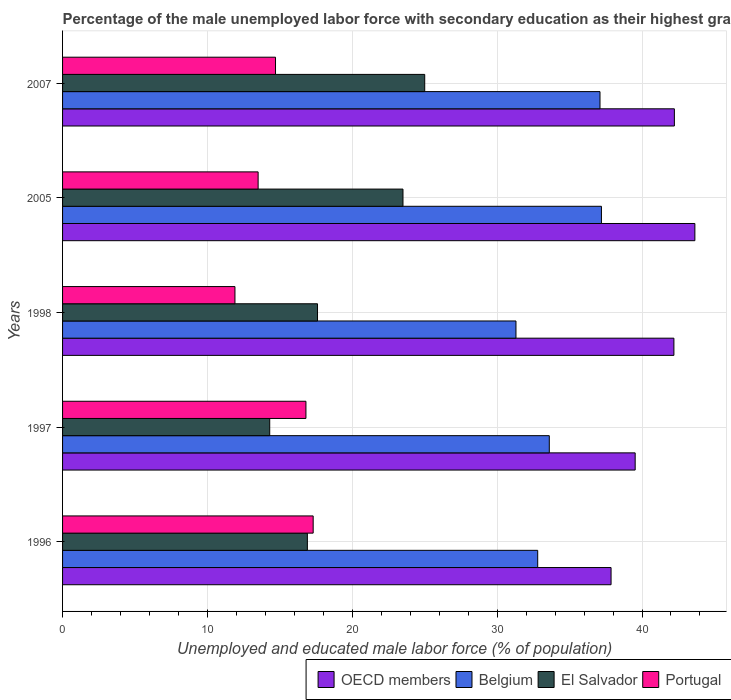How many different coloured bars are there?
Your response must be concise. 4. Are the number of bars per tick equal to the number of legend labels?
Ensure brevity in your answer.  Yes. What is the percentage of the unemployed male labor force with secondary education in Portugal in 1998?
Provide a short and direct response. 11.9. Across all years, what is the maximum percentage of the unemployed male labor force with secondary education in OECD members?
Provide a short and direct response. 43.65. Across all years, what is the minimum percentage of the unemployed male labor force with secondary education in Belgium?
Provide a succinct answer. 31.3. In which year was the percentage of the unemployed male labor force with secondary education in Belgium minimum?
Ensure brevity in your answer.  1998. What is the total percentage of the unemployed male labor force with secondary education in Portugal in the graph?
Your response must be concise. 74.2. What is the difference between the percentage of the unemployed male labor force with secondary education in Portugal in 1997 and that in 2005?
Make the answer very short. 3.3. What is the difference between the percentage of the unemployed male labor force with secondary education in OECD members in 2005 and the percentage of the unemployed male labor force with secondary education in Portugal in 1996?
Ensure brevity in your answer.  26.35. What is the average percentage of the unemployed male labor force with secondary education in Belgium per year?
Your answer should be compact. 34.4. In the year 2007, what is the difference between the percentage of the unemployed male labor force with secondary education in El Salvador and percentage of the unemployed male labor force with secondary education in Belgium?
Provide a short and direct response. -12.1. What is the ratio of the percentage of the unemployed male labor force with secondary education in OECD members in 1997 to that in 1998?
Make the answer very short. 0.94. What is the difference between the highest and the second highest percentage of the unemployed male labor force with secondary education in OECD members?
Your answer should be compact. 1.41. What is the difference between the highest and the lowest percentage of the unemployed male labor force with secondary education in OECD members?
Offer a terse response. 5.79. In how many years, is the percentage of the unemployed male labor force with secondary education in Belgium greater than the average percentage of the unemployed male labor force with secondary education in Belgium taken over all years?
Provide a short and direct response. 2. Is the sum of the percentage of the unemployed male labor force with secondary education in OECD members in 1996 and 1998 greater than the maximum percentage of the unemployed male labor force with secondary education in Portugal across all years?
Keep it short and to the point. Yes. Is it the case that in every year, the sum of the percentage of the unemployed male labor force with secondary education in El Salvador and percentage of the unemployed male labor force with secondary education in Belgium is greater than the sum of percentage of the unemployed male labor force with secondary education in Portugal and percentage of the unemployed male labor force with secondary education in OECD members?
Give a very brief answer. No. What does the 4th bar from the bottom in 1998 represents?
Your answer should be very brief. Portugal. How many bars are there?
Provide a short and direct response. 20. What is the difference between two consecutive major ticks on the X-axis?
Offer a very short reply. 10. Are the values on the major ticks of X-axis written in scientific E-notation?
Offer a very short reply. No. Where does the legend appear in the graph?
Keep it short and to the point. Bottom right. How many legend labels are there?
Your answer should be compact. 4. How are the legend labels stacked?
Keep it short and to the point. Horizontal. What is the title of the graph?
Provide a succinct answer. Percentage of the male unemployed labor force with secondary education as their highest grade. Does "South Sudan" appear as one of the legend labels in the graph?
Offer a terse response. No. What is the label or title of the X-axis?
Your answer should be compact. Unemployed and educated male labor force (% of population). What is the Unemployed and educated male labor force (% of population) of OECD members in 1996?
Ensure brevity in your answer.  37.86. What is the Unemployed and educated male labor force (% of population) in Belgium in 1996?
Offer a terse response. 32.8. What is the Unemployed and educated male labor force (% of population) in El Salvador in 1996?
Give a very brief answer. 16.9. What is the Unemployed and educated male labor force (% of population) of Portugal in 1996?
Offer a very short reply. 17.3. What is the Unemployed and educated male labor force (% of population) in OECD members in 1997?
Make the answer very short. 39.53. What is the Unemployed and educated male labor force (% of population) of Belgium in 1997?
Your response must be concise. 33.6. What is the Unemployed and educated male labor force (% of population) of El Salvador in 1997?
Your answer should be compact. 14.3. What is the Unemployed and educated male labor force (% of population) in Portugal in 1997?
Provide a short and direct response. 16.8. What is the Unemployed and educated male labor force (% of population) in OECD members in 1998?
Provide a succinct answer. 42.2. What is the Unemployed and educated male labor force (% of population) in Belgium in 1998?
Your answer should be compact. 31.3. What is the Unemployed and educated male labor force (% of population) of El Salvador in 1998?
Provide a succinct answer. 17.6. What is the Unemployed and educated male labor force (% of population) of Portugal in 1998?
Ensure brevity in your answer.  11.9. What is the Unemployed and educated male labor force (% of population) in OECD members in 2005?
Your answer should be compact. 43.65. What is the Unemployed and educated male labor force (% of population) in Belgium in 2005?
Give a very brief answer. 37.2. What is the Unemployed and educated male labor force (% of population) in Portugal in 2005?
Your response must be concise. 13.5. What is the Unemployed and educated male labor force (% of population) in OECD members in 2007?
Keep it short and to the point. 42.24. What is the Unemployed and educated male labor force (% of population) in Belgium in 2007?
Offer a very short reply. 37.1. What is the Unemployed and educated male labor force (% of population) in El Salvador in 2007?
Your answer should be very brief. 25. What is the Unemployed and educated male labor force (% of population) in Portugal in 2007?
Ensure brevity in your answer.  14.7. Across all years, what is the maximum Unemployed and educated male labor force (% of population) of OECD members?
Your answer should be very brief. 43.65. Across all years, what is the maximum Unemployed and educated male labor force (% of population) of Belgium?
Offer a very short reply. 37.2. Across all years, what is the maximum Unemployed and educated male labor force (% of population) of El Salvador?
Provide a succinct answer. 25. Across all years, what is the maximum Unemployed and educated male labor force (% of population) of Portugal?
Give a very brief answer. 17.3. Across all years, what is the minimum Unemployed and educated male labor force (% of population) in OECD members?
Offer a terse response. 37.86. Across all years, what is the minimum Unemployed and educated male labor force (% of population) of Belgium?
Provide a succinct answer. 31.3. Across all years, what is the minimum Unemployed and educated male labor force (% of population) of El Salvador?
Your answer should be very brief. 14.3. Across all years, what is the minimum Unemployed and educated male labor force (% of population) in Portugal?
Keep it short and to the point. 11.9. What is the total Unemployed and educated male labor force (% of population) of OECD members in the graph?
Offer a very short reply. 205.48. What is the total Unemployed and educated male labor force (% of population) of Belgium in the graph?
Offer a terse response. 172. What is the total Unemployed and educated male labor force (% of population) in El Salvador in the graph?
Your answer should be very brief. 97.3. What is the total Unemployed and educated male labor force (% of population) of Portugal in the graph?
Keep it short and to the point. 74.2. What is the difference between the Unemployed and educated male labor force (% of population) in OECD members in 1996 and that in 1997?
Offer a terse response. -1.67. What is the difference between the Unemployed and educated male labor force (% of population) of Portugal in 1996 and that in 1997?
Provide a short and direct response. 0.5. What is the difference between the Unemployed and educated male labor force (% of population) in OECD members in 1996 and that in 1998?
Give a very brief answer. -4.34. What is the difference between the Unemployed and educated male labor force (% of population) of Belgium in 1996 and that in 1998?
Keep it short and to the point. 1.5. What is the difference between the Unemployed and educated male labor force (% of population) of El Salvador in 1996 and that in 1998?
Ensure brevity in your answer.  -0.7. What is the difference between the Unemployed and educated male labor force (% of population) of OECD members in 1996 and that in 2005?
Make the answer very short. -5.79. What is the difference between the Unemployed and educated male labor force (% of population) in Portugal in 1996 and that in 2005?
Provide a succinct answer. 3.8. What is the difference between the Unemployed and educated male labor force (% of population) of OECD members in 1996 and that in 2007?
Your answer should be compact. -4.37. What is the difference between the Unemployed and educated male labor force (% of population) of Belgium in 1996 and that in 2007?
Your answer should be compact. -4.3. What is the difference between the Unemployed and educated male labor force (% of population) of Portugal in 1996 and that in 2007?
Offer a very short reply. 2.6. What is the difference between the Unemployed and educated male labor force (% of population) in OECD members in 1997 and that in 1998?
Give a very brief answer. -2.67. What is the difference between the Unemployed and educated male labor force (% of population) of Portugal in 1997 and that in 1998?
Offer a very short reply. 4.9. What is the difference between the Unemployed and educated male labor force (% of population) of OECD members in 1997 and that in 2005?
Offer a terse response. -4.12. What is the difference between the Unemployed and educated male labor force (% of population) in Portugal in 1997 and that in 2005?
Your answer should be compact. 3.3. What is the difference between the Unemployed and educated male labor force (% of population) of OECD members in 1997 and that in 2007?
Make the answer very short. -2.71. What is the difference between the Unemployed and educated male labor force (% of population) in El Salvador in 1997 and that in 2007?
Give a very brief answer. -10.7. What is the difference between the Unemployed and educated male labor force (% of population) of OECD members in 1998 and that in 2005?
Provide a succinct answer. -1.45. What is the difference between the Unemployed and educated male labor force (% of population) of Belgium in 1998 and that in 2005?
Offer a very short reply. -5.9. What is the difference between the Unemployed and educated male labor force (% of population) of OECD members in 1998 and that in 2007?
Give a very brief answer. -0.03. What is the difference between the Unemployed and educated male labor force (% of population) in OECD members in 2005 and that in 2007?
Give a very brief answer. 1.41. What is the difference between the Unemployed and educated male labor force (% of population) in Belgium in 2005 and that in 2007?
Offer a very short reply. 0.1. What is the difference between the Unemployed and educated male labor force (% of population) in El Salvador in 2005 and that in 2007?
Ensure brevity in your answer.  -1.5. What is the difference between the Unemployed and educated male labor force (% of population) of Portugal in 2005 and that in 2007?
Your response must be concise. -1.2. What is the difference between the Unemployed and educated male labor force (% of population) of OECD members in 1996 and the Unemployed and educated male labor force (% of population) of Belgium in 1997?
Provide a short and direct response. 4.26. What is the difference between the Unemployed and educated male labor force (% of population) of OECD members in 1996 and the Unemployed and educated male labor force (% of population) of El Salvador in 1997?
Provide a short and direct response. 23.56. What is the difference between the Unemployed and educated male labor force (% of population) of OECD members in 1996 and the Unemployed and educated male labor force (% of population) of Portugal in 1997?
Your response must be concise. 21.06. What is the difference between the Unemployed and educated male labor force (% of population) of Belgium in 1996 and the Unemployed and educated male labor force (% of population) of El Salvador in 1997?
Ensure brevity in your answer.  18.5. What is the difference between the Unemployed and educated male labor force (% of population) of El Salvador in 1996 and the Unemployed and educated male labor force (% of population) of Portugal in 1997?
Your response must be concise. 0.1. What is the difference between the Unemployed and educated male labor force (% of population) of OECD members in 1996 and the Unemployed and educated male labor force (% of population) of Belgium in 1998?
Provide a short and direct response. 6.56. What is the difference between the Unemployed and educated male labor force (% of population) of OECD members in 1996 and the Unemployed and educated male labor force (% of population) of El Salvador in 1998?
Your answer should be compact. 20.26. What is the difference between the Unemployed and educated male labor force (% of population) in OECD members in 1996 and the Unemployed and educated male labor force (% of population) in Portugal in 1998?
Keep it short and to the point. 25.96. What is the difference between the Unemployed and educated male labor force (% of population) of Belgium in 1996 and the Unemployed and educated male labor force (% of population) of El Salvador in 1998?
Ensure brevity in your answer.  15.2. What is the difference between the Unemployed and educated male labor force (% of population) of Belgium in 1996 and the Unemployed and educated male labor force (% of population) of Portugal in 1998?
Ensure brevity in your answer.  20.9. What is the difference between the Unemployed and educated male labor force (% of population) in El Salvador in 1996 and the Unemployed and educated male labor force (% of population) in Portugal in 1998?
Your response must be concise. 5. What is the difference between the Unemployed and educated male labor force (% of population) of OECD members in 1996 and the Unemployed and educated male labor force (% of population) of Belgium in 2005?
Your response must be concise. 0.66. What is the difference between the Unemployed and educated male labor force (% of population) in OECD members in 1996 and the Unemployed and educated male labor force (% of population) in El Salvador in 2005?
Ensure brevity in your answer.  14.36. What is the difference between the Unemployed and educated male labor force (% of population) of OECD members in 1996 and the Unemployed and educated male labor force (% of population) of Portugal in 2005?
Your answer should be very brief. 24.36. What is the difference between the Unemployed and educated male labor force (% of population) in Belgium in 1996 and the Unemployed and educated male labor force (% of population) in El Salvador in 2005?
Offer a terse response. 9.3. What is the difference between the Unemployed and educated male labor force (% of population) of Belgium in 1996 and the Unemployed and educated male labor force (% of population) of Portugal in 2005?
Offer a very short reply. 19.3. What is the difference between the Unemployed and educated male labor force (% of population) in El Salvador in 1996 and the Unemployed and educated male labor force (% of population) in Portugal in 2005?
Provide a short and direct response. 3.4. What is the difference between the Unemployed and educated male labor force (% of population) in OECD members in 1996 and the Unemployed and educated male labor force (% of population) in Belgium in 2007?
Your response must be concise. 0.76. What is the difference between the Unemployed and educated male labor force (% of population) in OECD members in 1996 and the Unemployed and educated male labor force (% of population) in El Salvador in 2007?
Offer a very short reply. 12.86. What is the difference between the Unemployed and educated male labor force (% of population) in OECD members in 1996 and the Unemployed and educated male labor force (% of population) in Portugal in 2007?
Give a very brief answer. 23.16. What is the difference between the Unemployed and educated male labor force (% of population) in El Salvador in 1996 and the Unemployed and educated male labor force (% of population) in Portugal in 2007?
Offer a very short reply. 2.2. What is the difference between the Unemployed and educated male labor force (% of population) of OECD members in 1997 and the Unemployed and educated male labor force (% of population) of Belgium in 1998?
Ensure brevity in your answer.  8.23. What is the difference between the Unemployed and educated male labor force (% of population) of OECD members in 1997 and the Unemployed and educated male labor force (% of population) of El Salvador in 1998?
Give a very brief answer. 21.93. What is the difference between the Unemployed and educated male labor force (% of population) of OECD members in 1997 and the Unemployed and educated male labor force (% of population) of Portugal in 1998?
Keep it short and to the point. 27.63. What is the difference between the Unemployed and educated male labor force (% of population) of Belgium in 1997 and the Unemployed and educated male labor force (% of population) of El Salvador in 1998?
Provide a succinct answer. 16. What is the difference between the Unemployed and educated male labor force (% of population) in Belgium in 1997 and the Unemployed and educated male labor force (% of population) in Portugal in 1998?
Your answer should be very brief. 21.7. What is the difference between the Unemployed and educated male labor force (% of population) in OECD members in 1997 and the Unemployed and educated male labor force (% of population) in Belgium in 2005?
Keep it short and to the point. 2.33. What is the difference between the Unemployed and educated male labor force (% of population) in OECD members in 1997 and the Unemployed and educated male labor force (% of population) in El Salvador in 2005?
Provide a short and direct response. 16.03. What is the difference between the Unemployed and educated male labor force (% of population) of OECD members in 1997 and the Unemployed and educated male labor force (% of population) of Portugal in 2005?
Offer a terse response. 26.03. What is the difference between the Unemployed and educated male labor force (% of population) of Belgium in 1997 and the Unemployed and educated male labor force (% of population) of Portugal in 2005?
Keep it short and to the point. 20.1. What is the difference between the Unemployed and educated male labor force (% of population) in OECD members in 1997 and the Unemployed and educated male labor force (% of population) in Belgium in 2007?
Your response must be concise. 2.43. What is the difference between the Unemployed and educated male labor force (% of population) of OECD members in 1997 and the Unemployed and educated male labor force (% of population) of El Salvador in 2007?
Make the answer very short. 14.53. What is the difference between the Unemployed and educated male labor force (% of population) of OECD members in 1997 and the Unemployed and educated male labor force (% of population) of Portugal in 2007?
Your answer should be compact. 24.83. What is the difference between the Unemployed and educated male labor force (% of population) of Belgium in 1997 and the Unemployed and educated male labor force (% of population) of El Salvador in 2007?
Your response must be concise. 8.6. What is the difference between the Unemployed and educated male labor force (% of population) of El Salvador in 1997 and the Unemployed and educated male labor force (% of population) of Portugal in 2007?
Keep it short and to the point. -0.4. What is the difference between the Unemployed and educated male labor force (% of population) of OECD members in 1998 and the Unemployed and educated male labor force (% of population) of Belgium in 2005?
Offer a terse response. 5. What is the difference between the Unemployed and educated male labor force (% of population) of OECD members in 1998 and the Unemployed and educated male labor force (% of population) of El Salvador in 2005?
Provide a succinct answer. 18.7. What is the difference between the Unemployed and educated male labor force (% of population) of OECD members in 1998 and the Unemployed and educated male labor force (% of population) of Portugal in 2005?
Ensure brevity in your answer.  28.7. What is the difference between the Unemployed and educated male labor force (% of population) of Belgium in 1998 and the Unemployed and educated male labor force (% of population) of Portugal in 2005?
Offer a terse response. 17.8. What is the difference between the Unemployed and educated male labor force (% of population) in El Salvador in 1998 and the Unemployed and educated male labor force (% of population) in Portugal in 2005?
Provide a succinct answer. 4.1. What is the difference between the Unemployed and educated male labor force (% of population) in OECD members in 1998 and the Unemployed and educated male labor force (% of population) in Belgium in 2007?
Your response must be concise. 5.1. What is the difference between the Unemployed and educated male labor force (% of population) in OECD members in 1998 and the Unemployed and educated male labor force (% of population) in El Salvador in 2007?
Your answer should be very brief. 17.2. What is the difference between the Unemployed and educated male labor force (% of population) in OECD members in 1998 and the Unemployed and educated male labor force (% of population) in Portugal in 2007?
Provide a succinct answer. 27.5. What is the difference between the Unemployed and educated male labor force (% of population) of Belgium in 1998 and the Unemployed and educated male labor force (% of population) of El Salvador in 2007?
Your answer should be compact. 6.3. What is the difference between the Unemployed and educated male labor force (% of population) of Belgium in 1998 and the Unemployed and educated male labor force (% of population) of Portugal in 2007?
Ensure brevity in your answer.  16.6. What is the difference between the Unemployed and educated male labor force (% of population) of OECD members in 2005 and the Unemployed and educated male labor force (% of population) of Belgium in 2007?
Your answer should be compact. 6.55. What is the difference between the Unemployed and educated male labor force (% of population) in OECD members in 2005 and the Unemployed and educated male labor force (% of population) in El Salvador in 2007?
Provide a short and direct response. 18.65. What is the difference between the Unemployed and educated male labor force (% of population) in OECD members in 2005 and the Unemployed and educated male labor force (% of population) in Portugal in 2007?
Provide a succinct answer. 28.95. What is the difference between the Unemployed and educated male labor force (% of population) in Belgium in 2005 and the Unemployed and educated male labor force (% of population) in Portugal in 2007?
Your answer should be very brief. 22.5. What is the difference between the Unemployed and educated male labor force (% of population) in El Salvador in 2005 and the Unemployed and educated male labor force (% of population) in Portugal in 2007?
Offer a terse response. 8.8. What is the average Unemployed and educated male labor force (% of population) in OECD members per year?
Provide a short and direct response. 41.1. What is the average Unemployed and educated male labor force (% of population) in Belgium per year?
Ensure brevity in your answer.  34.4. What is the average Unemployed and educated male labor force (% of population) of El Salvador per year?
Your answer should be compact. 19.46. What is the average Unemployed and educated male labor force (% of population) of Portugal per year?
Your answer should be compact. 14.84. In the year 1996, what is the difference between the Unemployed and educated male labor force (% of population) in OECD members and Unemployed and educated male labor force (% of population) in Belgium?
Your response must be concise. 5.06. In the year 1996, what is the difference between the Unemployed and educated male labor force (% of population) in OECD members and Unemployed and educated male labor force (% of population) in El Salvador?
Your answer should be very brief. 20.96. In the year 1996, what is the difference between the Unemployed and educated male labor force (% of population) in OECD members and Unemployed and educated male labor force (% of population) in Portugal?
Provide a succinct answer. 20.56. In the year 1996, what is the difference between the Unemployed and educated male labor force (% of population) of El Salvador and Unemployed and educated male labor force (% of population) of Portugal?
Make the answer very short. -0.4. In the year 1997, what is the difference between the Unemployed and educated male labor force (% of population) of OECD members and Unemployed and educated male labor force (% of population) of Belgium?
Offer a very short reply. 5.93. In the year 1997, what is the difference between the Unemployed and educated male labor force (% of population) in OECD members and Unemployed and educated male labor force (% of population) in El Salvador?
Provide a succinct answer. 25.23. In the year 1997, what is the difference between the Unemployed and educated male labor force (% of population) of OECD members and Unemployed and educated male labor force (% of population) of Portugal?
Make the answer very short. 22.73. In the year 1997, what is the difference between the Unemployed and educated male labor force (% of population) of Belgium and Unemployed and educated male labor force (% of population) of El Salvador?
Offer a terse response. 19.3. In the year 1997, what is the difference between the Unemployed and educated male labor force (% of population) of Belgium and Unemployed and educated male labor force (% of population) of Portugal?
Make the answer very short. 16.8. In the year 1998, what is the difference between the Unemployed and educated male labor force (% of population) in OECD members and Unemployed and educated male labor force (% of population) in Belgium?
Keep it short and to the point. 10.9. In the year 1998, what is the difference between the Unemployed and educated male labor force (% of population) of OECD members and Unemployed and educated male labor force (% of population) of El Salvador?
Ensure brevity in your answer.  24.6. In the year 1998, what is the difference between the Unemployed and educated male labor force (% of population) in OECD members and Unemployed and educated male labor force (% of population) in Portugal?
Provide a succinct answer. 30.3. In the year 1998, what is the difference between the Unemployed and educated male labor force (% of population) of Belgium and Unemployed and educated male labor force (% of population) of Portugal?
Keep it short and to the point. 19.4. In the year 2005, what is the difference between the Unemployed and educated male labor force (% of population) of OECD members and Unemployed and educated male labor force (% of population) of Belgium?
Provide a succinct answer. 6.45. In the year 2005, what is the difference between the Unemployed and educated male labor force (% of population) of OECD members and Unemployed and educated male labor force (% of population) of El Salvador?
Give a very brief answer. 20.15. In the year 2005, what is the difference between the Unemployed and educated male labor force (% of population) in OECD members and Unemployed and educated male labor force (% of population) in Portugal?
Your answer should be compact. 30.15. In the year 2005, what is the difference between the Unemployed and educated male labor force (% of population) of Belgium and Unemployed and educated male labor force (% of population) of Portugal?
Keep it short and to the point. 23.7. In the year 2007, what is the difference between the Unemployed and educated male labor force (% of population) of OECD members and Unemployed and educated male labor force (% of population) of Belgium?
Your answer should be very brief. 5.14. In the year 2007, what is the difference between the Unemployed and educated male labor force (% of population) in OECD members and Unemployed and educated male labor force (% of population) in El Salvador?
Your response must be concise. 17.24. In the year 2007, what is the difference between the Unemployed and educated male labor force (% of population) in OECD members and Unemployed and educated male labor force (% of population) in Portugal?
Offer a terse response. 27.54. In the year 2007, what is the difference between the Unemployed and educated male labor force (% of population) in Belgium and Unemployed and educated male labor force (% of population) in Portugal?
Make the answer very short. 22.4. In the year 2007, what is the difference between the Unemployed and educated male labor force (% of population) of El Salvador and Unemployed and educated male labor force (% of population) of Portugal?
Provide a short and direct response. 10.3. What is the ratio of the Unemployed and educated male labor force (% of population) of OECD members in 1996 to that in 1997?
Provide a short and direct response. 0.96. What is the ratio of the Unemployed and educated male labor force (% of population) of Belgium in 1996 to that in 1997?
Provide a short and direct response. 0.98. What is the ratio of the Unemployed and educated male labor force (% of population) of El Salvador in 1996 to that in 1997?
Make the answer very short. 1.18. What is the ratio of the Unemployed and educated male labor force (% of population) in Portugal in 1996 to that in 1997?
Offer a terse response. 1.03. What is the ratio of the Unemployed and educated male labor force (% of population) in OECD members in 1996 to that in 1998?
Provide a short and direct response. 0.9. What is the ratio of the Unemployed and educated male labor force (% of population) in Belgium in 1996 to that in 1998?
Make the answer very short. 1.05. What is the ratio of the Unemployed and educated male labor force (% of population) in El Salvador in 1996 to that in 1998?
Your answer should be compact. 0.96. What is the ratio of the Unemployed and educated male labor force (% of population) of Portugal in 1996 to that in 1998?
Provide a succinct answer. 1.45. What is the ratio of the Unemployed and educated male labor force (% of population) of OECD members in 1996 to that in 2005?
Your response must be concise. 0.87. What is the ratio of the Unemployed and educated male labor force (% of population) in Belgium in 1996 to that in 2005?
Your answer should be very brief. 0.88. What is the ratio of the Unemployed and educated male labor force (% of population) in El Salvador in 1996 to that in 2005?
Provide a short and direct response. 0.72. What is the ratio of the Unemployed and educated male labor force (% of population) in Portugal in 1996 to that in 2005?
Provide a succinct answer. 1.28. What is the ratio of the Unemployed and educated male labor force (% of population) of OECD members in 1996 to that in 2007?
Offer a very short reply. 0.9. What is the ratio of the Unemployed and educated male labor force (% of population) of Belgium in 1996 to that in 2007?
Keep it short and to the point. 0.88. What is the ratio of the Unemployed and educated male labor force (% of population) of El Salvador in 1996 to that in 2007?
Your answer should be compact. 0.68. What is the ratio of the Unemployed and educated male labor force (% of population) of Portugal in 1996 to that in 2007?
Your answer should be very brief. 1.18. What is the ratio of the Unemployed and educated male labor force (% of population) in OECD members in 1997 to that in 1998?
Ensure brevity in your answer.  0.94. What is the ratio of the Unemployed and educated male labor force (% of population) of Belgium in 1997 to that in 1998?
Your answer should be compact. 1.07. What is the ratio of the Unemployed and educated male labor force (% of population) of El Salvador in 1997 to that in 1998?
Your answer should be very brief. 0.81. What is the ratio of the Unemployed and educated male labor force (% of population) in Portugal in 1997 to that in 1998?
Offer a very short reply. 1.41. What is the ratio of the Unemployed and educated male labor force (% of population) of OECD members in 1997 to that in 2005?
Offer a very short reply. 0.91. What is the ratio of the Unemployed and educated male labor force (% of population) in Belgium in 1997 to that in 2005?
Provide a short and direct response. 0.9. What is the ratio of the Unemployed and educated male labor force (% of population) of El Salvador in 1997 to that in 2005?
Keep it short and to the point. 0.61. What is the ratio of the Unemployed and educated male labor force (% of population) in Portugal in 1997 to that in 2005?
Offer a very short reply. 1.24. What is the ratio of the Unemployed and educated male labor force (% of population) of OECD members in 1997 to that in 2007?
Give a very brief answer. 0.94. What is the ratio of the Unemployed and educated male labor force (% of population) of Belgium in 1997 to that in 2007?
Give a very brief answer. 0.91. What is the ratio of the Unemployed and educated male labor force (% of population) of El Salvador in 1997 to that in 2007?
Provide a succinct answer. 0.57. What is the ratio of the Unemployed and educated male labor force (% of population) in Portugal in 1997 to that in 2007?
Offer a terse response. 1.14. What is the ratio of the Unemployed and educated male labor force (% of population) of OECD members in 1998 to that in 2005?
Offer a very short reply. 0.97. What is the ratio of the Unemployed and educated male labor force (% of population) in Belgium in 1998 to that in 2005?
Ensure brevity in your answer.  0.84. What is the ratio of the Unemployed and educated male labor force (% of population) of El Salvador in 1998 to that in 2005?
Keep it short and to the point. 0.75. What is the ratio of the Unemployed and educated male labor force (% of population) of Portugal in 1998 to that in 2005?
Give a very brief answer. 0.88. What is the ratio of the Unemployed and educated male labor force (% of population) in Belgium in 1998 to that in 2007?
Your response must be concise. 0.84. What is the ratio of the Unemployed and educated male labor force (% of population) of El Salvador in 1998 to that in 2007?
Make the answer very short. 0.7. What is the ratio of the Unemployed and educated male labor force (% of population) in Portugal in 1998 to that in 2007?
Offer a very short reply. 0.81. What is the ratio of the Unemployed and educated male labor force (% of population) of OECD members in 2005 to that in 2007?
Your answer should be very brief. 1.03. What is the ratio of the Unemployed and educated male labor force (% of population) in Portugal in 2005 to that in 2007?
Your answer should be very brief. 0.92. What is the difference between the highest and the second highest Unemployed and educated male labor force (% of population) of OECD members?
Provide a succinct answer. 1.41. What is the difference between the highest and the second highest Unemployed and educated male labor force (% of population) of Belgium?
Give a very brief answer. 0.1. What is the difference between the highest and the second highest Unemployed and educated male labor force (% of population) in El Salvador?
Ensure brevity in your answer.  1.5. What is the difference between the highest and the lowest Unemployed and educated male labor force (% of population) in OECD members?
Offer a terse response. 5.79. What is the difference between the highest and the lowest Unemployed and educated male labor force (% of population) in El Salvador?
Offer a terse response. 10.7. 